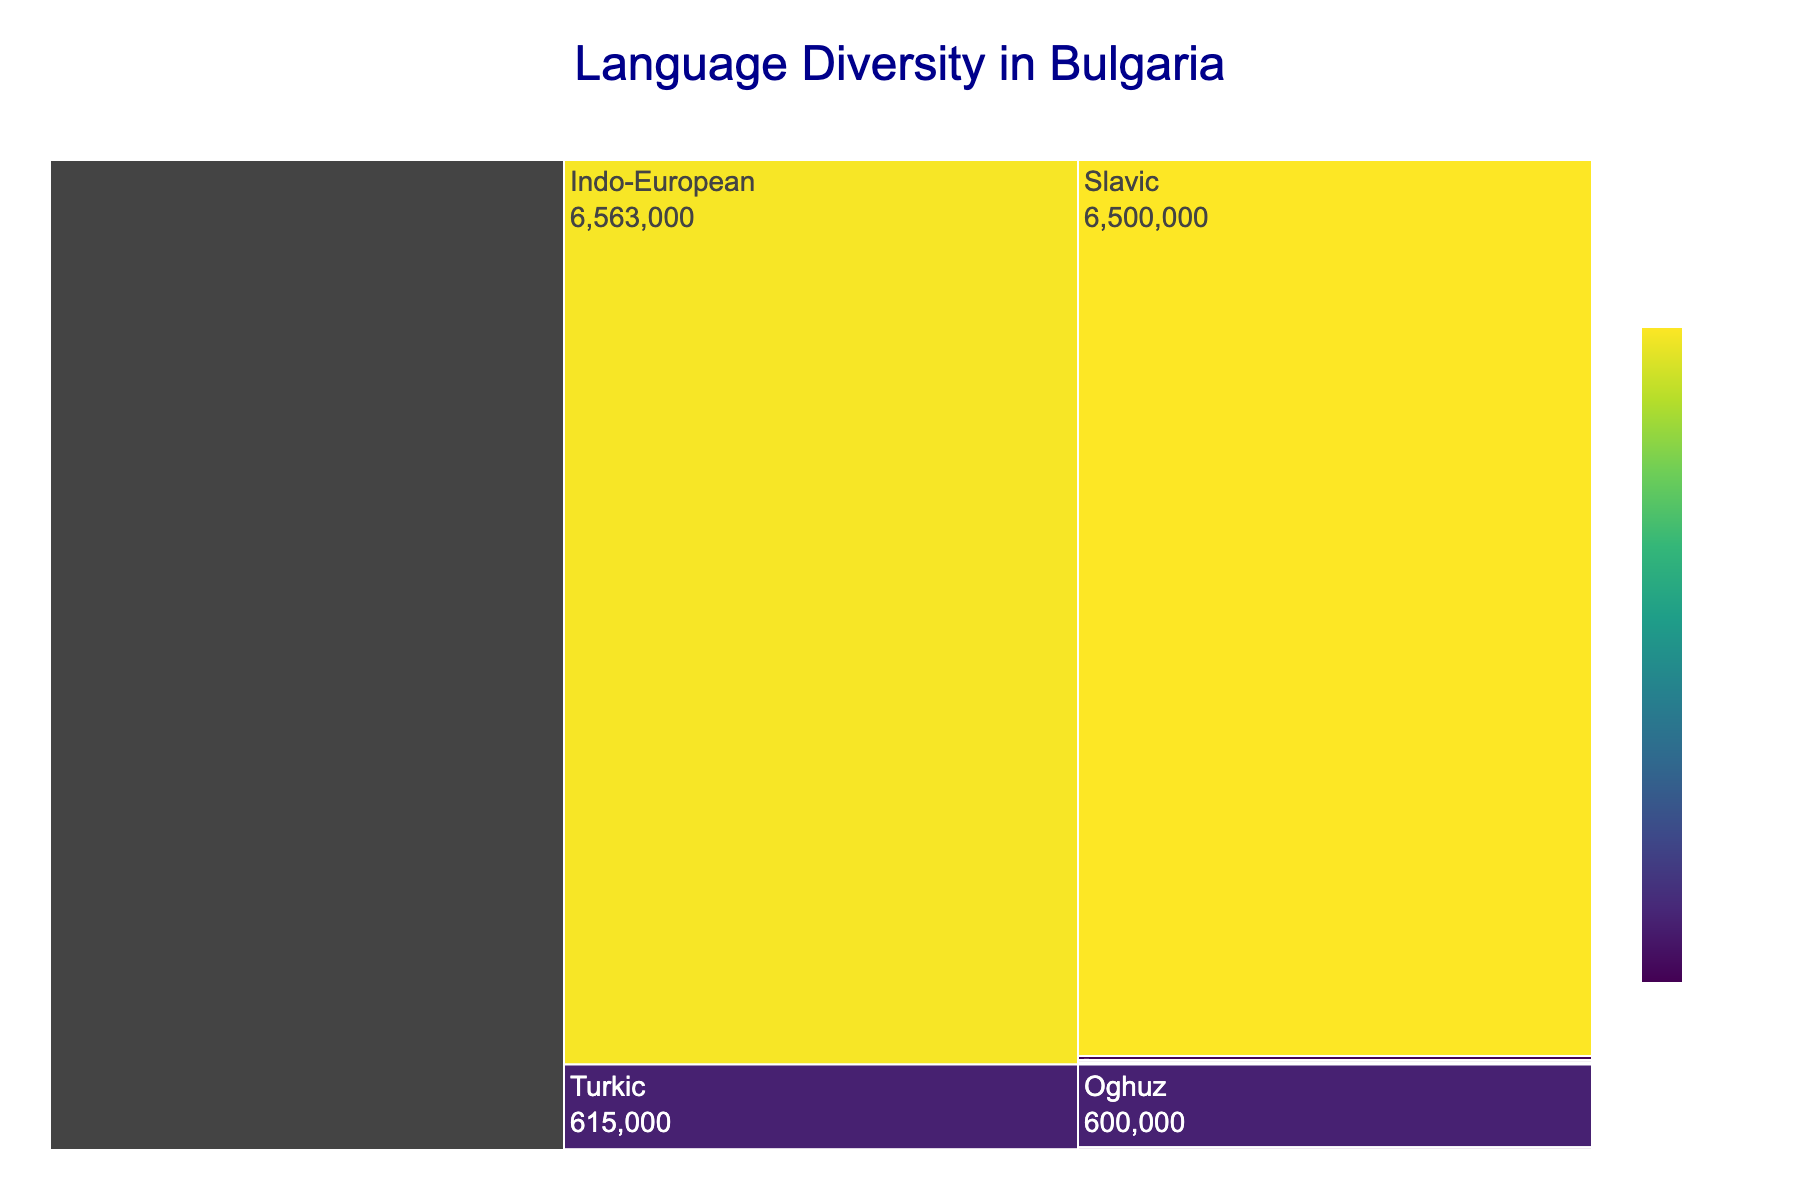What is the title of the icicle chart? The title of the chart is clearly stated at the top center of the plot, usually in a larger and distinct font.
Answer: Language Diversity in Bulgaria Which linguistic family has the largest number of speakers? By looking at the segments of the icicle chart, the segment with the highest numerical value represents the linguistic family with the largest number of speakers.
Answer: Indo-European How many speakers are there for the Turkic linguistic family? Locate the Turkic segment in the icicle chart and sum the values from its subcategories. According to the data, it includes Oghuz with 600,000 speakers and Kipchak with 15,000 speakers.
Answer: 615,000 Which subfamily under Indo-European has the second largest number of speakers? Examine the subfamily segments under the Indo-European family and find the one with the second highest value. Based on the values, the Slavic subfamily has 6,500,000 speakers, while the Romance subfamily has 30,000 speakers, making Romance the second largest.
Answer: Romance Are there more speakers of the Germanic subfamily or the Armenian subfamily? Compare the values of the Germanic and the Armenian subfamilies under the Indo-European family. Germanic has 8,000 speakers and Armenian has 10,000 speakers.
Answer: Armenian What is the total number of speakers in the Indo-European linguistic family? Sum the values of all the subfamilies under Indo-European, which are Slavic (6,500,000), Romance (30,000), Greek (15,000), Armenian (10,000), and Germanic (8,000). The calculation is 6,500,000 + 30,000 + 15,000 + 10,000 + 8,000.
Answer: 6,563,000 What is the difference in the number of speakers between the Oghuz and Kipchak subfamilies under the Turkic linguistic family? Subtract the number of speakers in the Kipchak subfamily from the Oghuz subfamily. According to the data, Oghuz has 600,000 and Kipchak has 15,000 speakers, so the difference is 600,000 - 15,000.
Answer: 585,000 Which linguistic family has the least number of speakers? Check the values of all the linguistic families and identify the one with the smallest value. From the data, Uralic has 3,000 and Afroasiatic has 1,500 speakers, making Afroasiatic the family with the least number of speakers.
Answer: Afroasiatic How many linguistic families are represented in the chart? Count the distinct category elements in the data, which represent the different linguistic families.
Answer: 4 Compare the number of speakers in the Slavic subfamily to the total number of speakers in all non-Indo-European families. First, sum the values of all non-Indo-European families: Turkic (615,000), Uralic (3,000), and Afroasiatic (1,500). The calculation is 615,000 + 3,000 + 1,500 = 619,500. The Slavic subfamily has 6,500,000 speakers, so compare these two values.
Answer: Slavic is significantly more 